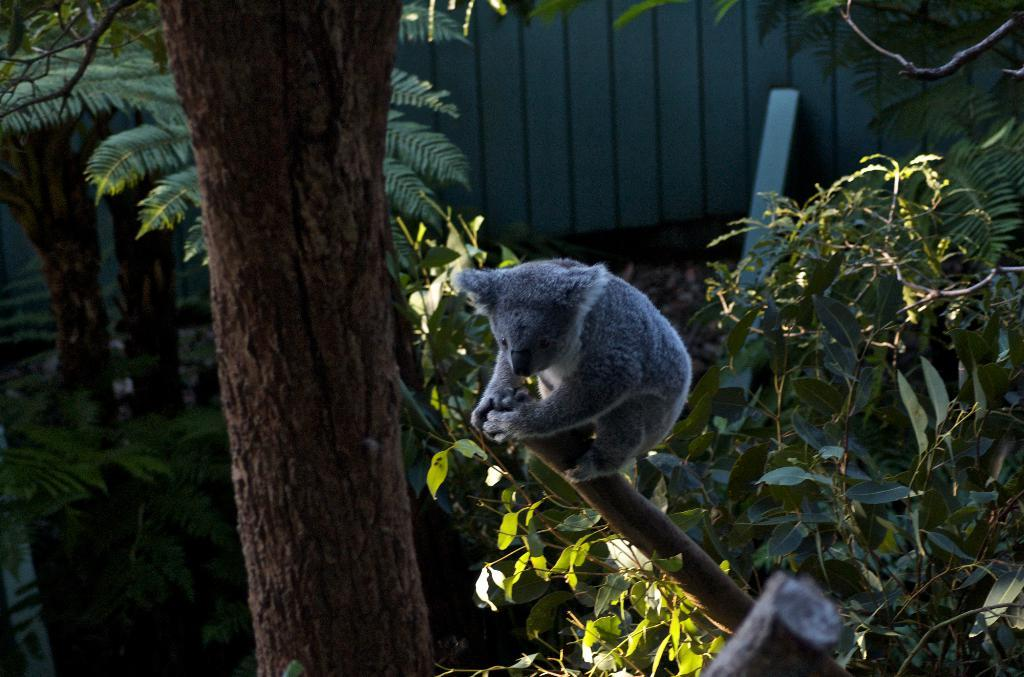What is on the tree in the image? There is an animal on the tree in the image. What can be seen in the background of the image? There is a wall and trees in the background of the image. Can you describe the object in the background? Unfortunately, the facts provided do not give enough information to describe the object in the background. What type of quartz is being used to cover the animal in the image? There is no quartz or any type of covering visible on the animal in the image. 